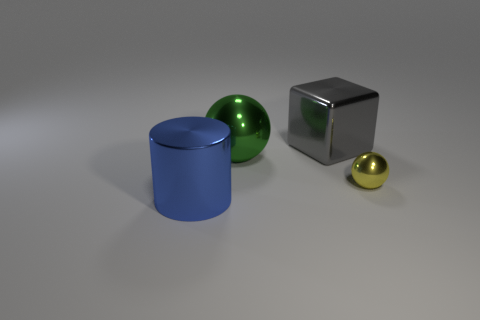Add 4 purple rubber blocks. How many objects exist? 8 Subtract all blocks. How many objects are left? 3 Add 1 big green metal objects. How many big green metal objects are left? 2 Add 2 tiny blue rubber cylinders. How many tiny blue rubber cylinders exist? 2 Subtract 0 brown balls. How many objects are left? 4 Subtract all tiny green shiny objects. Subtract all yellow metallic balls. How many objects are left? 3 